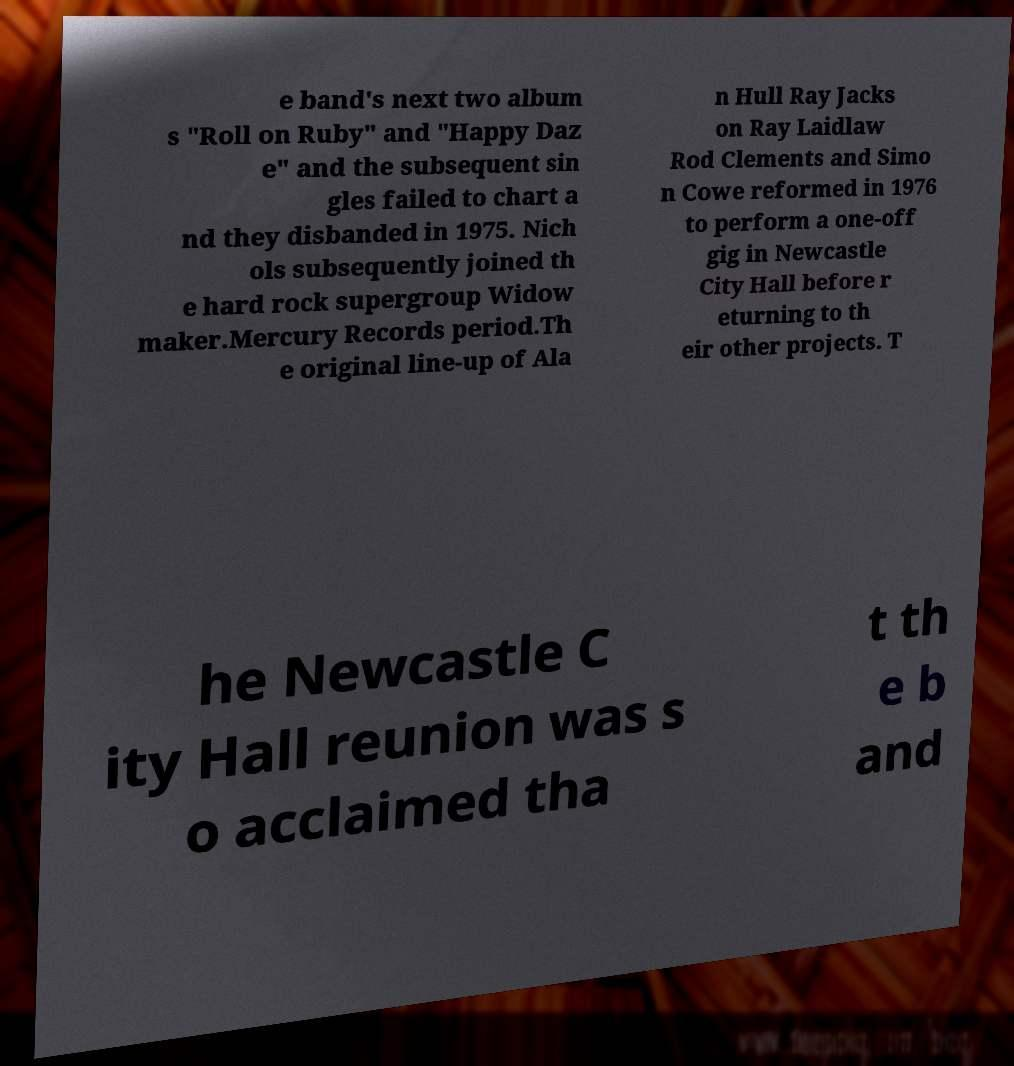Please identify and transcribe the text found in this image. e band's next two album s "Roll on Ruby" and "Happy Daz e" and the subsequent sin gles failed to chart a nd they disbanded in 1975. Nich ols subsequently joined th e hard rock supergroup Widow maker.Mercury Records period.Th e original line-up of Ala n Hull Ray Jacks on Ray Laidlaw Rod Clements and Simo n Cowe reformed in 1976 to perform a one-off gig in Newcastle City Hall before r eturning to th eir other projects. T he Newcastle C ity Hall reunion was s o acclaimed tha t th e b and 